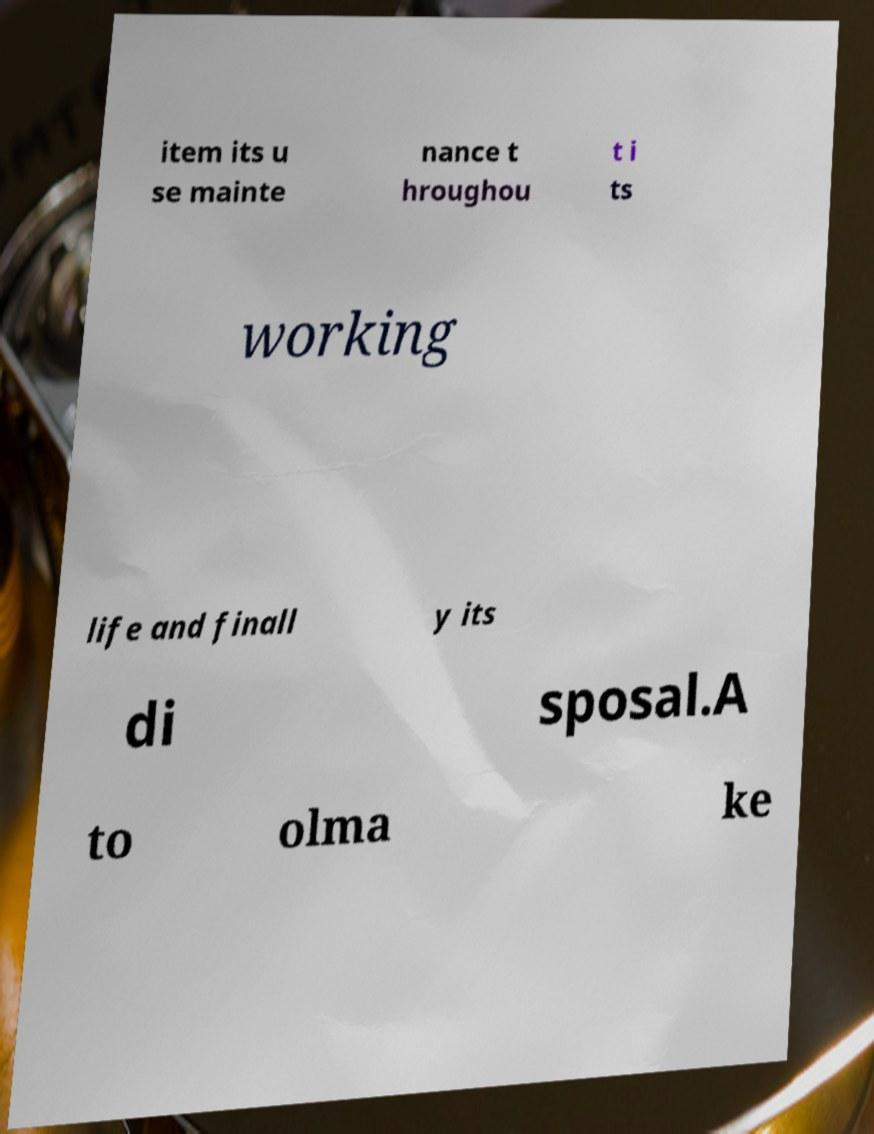There's text embedded in this image that I need extracted. Can you transcribe it verbatim? item its u se mainte nance t hroughou t i ts working life and finall y its di sposal.A to olma ke 